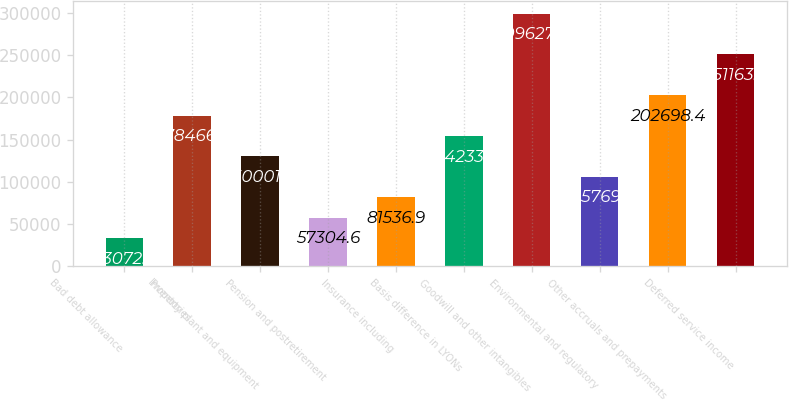Convert chart to OTSL. <chart><loc_0><loc_0><loc_500><loc_500><bar_chart><fcel>Bad debt allowance<fcel>Inventories<fcel>Property plant and equipment<fcel>Pension and postretirement<fcel>Insurance including<fcel>Basis difference in LYONs<fcel>Goodwill and other intangibles<fcel>Environmental and regulatory<fcel>Other accruals and prepayments<fcel>Deferred service income<nl><fcel>33072.3<fcel>178466<fcel>130002<fcel>57304.6<fcel>81536.9<fcel>154234<fcel>299628<fcel>105769<fcel>202698<fcel>251163<nl></chart> 